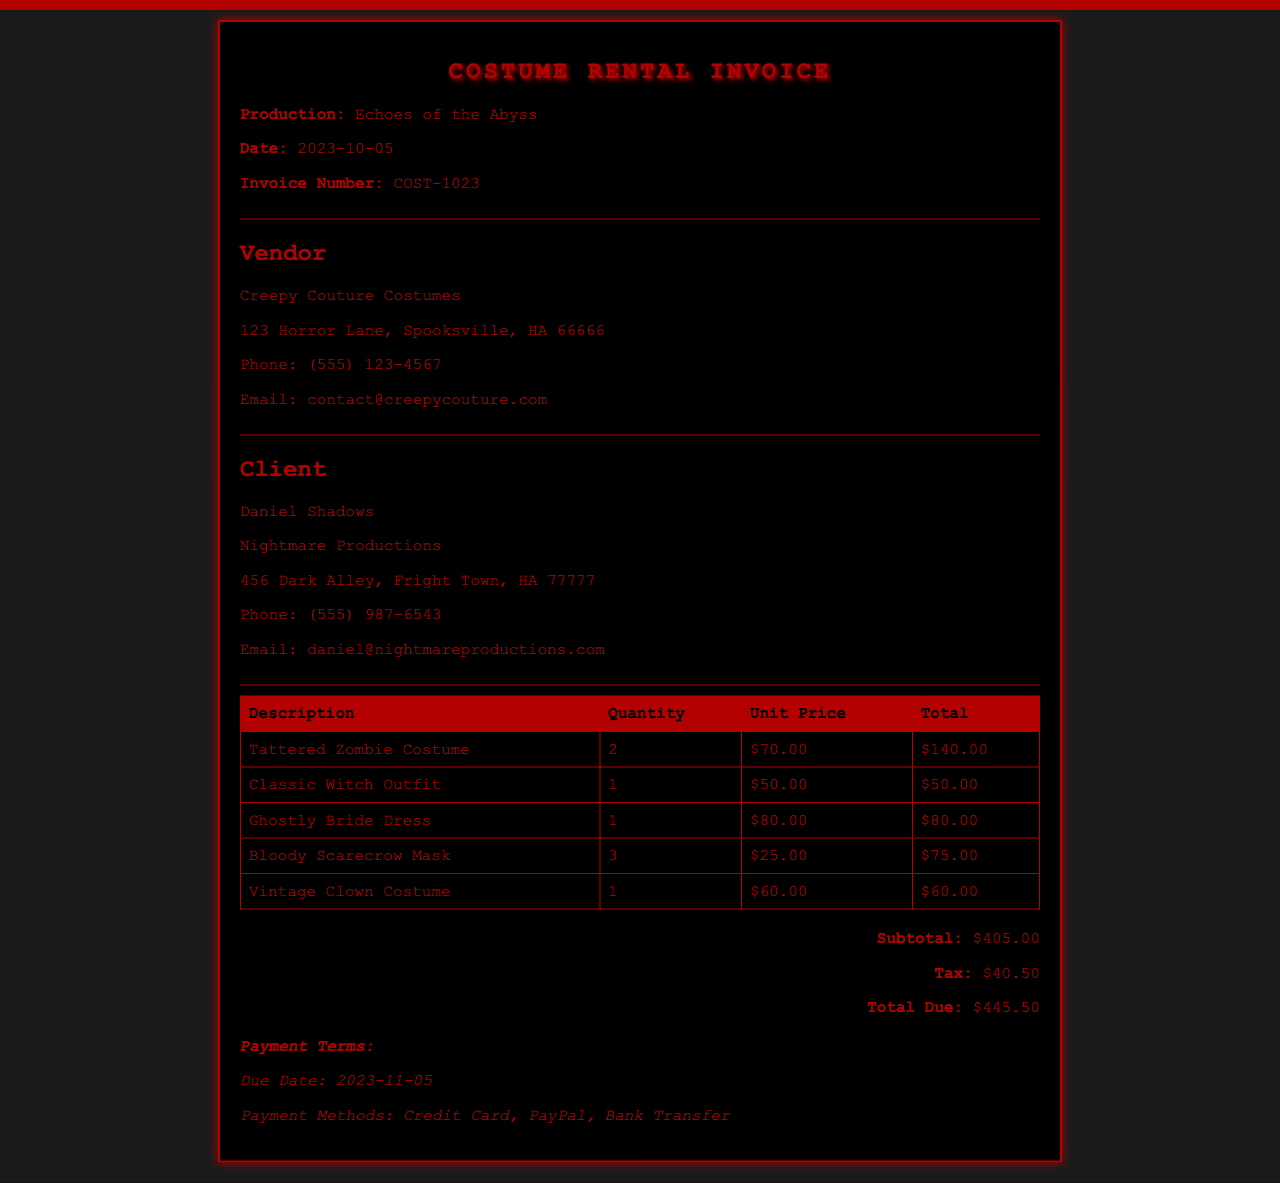What is the total due amount? The total due amount is the final figure at the bottom of the invoice, which includes subtotal and tax.
Answer: $445.50 Who is the client? The client is mentioned in the client section of the invoice and includes the client's name and company.
Answer: Daniel Shadows, Nightmare Productions What is the quantity of the Tattered Zombie Costume? The quantity is provided in the table under the Quantity column for each costume piece.
Answer: 2 When is the payment due date? The payment due date is stated clearly under the payment terms section of the invoice.
Answer: 2023-11-05 What is the subtotal before tax? The subtotal is indicated before tax in the summary section of the invoice.
Answer: $405.00 How many Bloody Scarecrow Masks were rented? The number of Bloody Scarecrow Masks rented is listed in the table under Quantity for that item.
Answer: 3 What vendor provided the costumes? The vendor information is provided clearly in the invoice, including the name and address.
Answer: Creepy Couture Costumes What is the unit price of the Ghostly Bride Dress? The unit price is mentioned in the table next to the description of the Ghostly Bride Dress.
Answer: $80.00 What are the payment methods accepted? The accepted payment methods are specified under the payment terms section of the invoice.
Answer: Credit Card, PayPal, Bank Transfer 